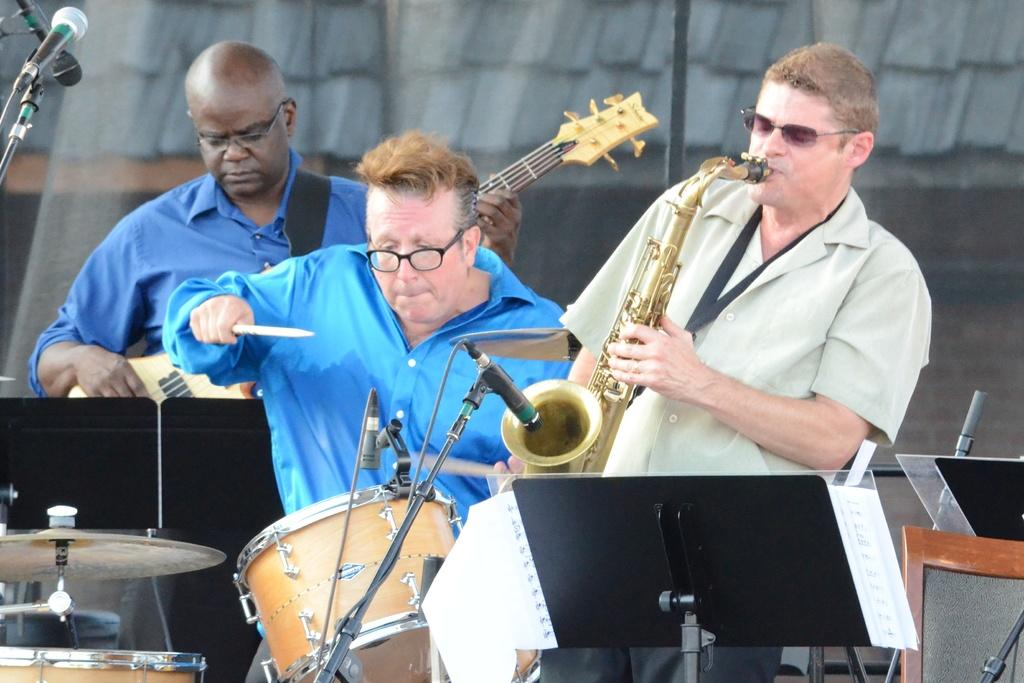How many persons are playing musical instruments in the image? There are three persons playing musical instruments in the image. What else can be seen in the image besides the persons playing instruments? There are book stands, a paper on a book stand, microphones, and a building in the background of the image. What type of metal can be seen in the image? There is no specific metal mentioned or visible in the image. Who is the creator of the paper on the book stand? The image does not provide information about the creator of the paper on the book stand. 